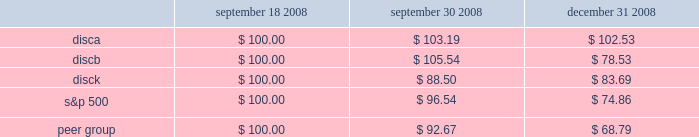2 0 0 8 a n n u a l r e p o r t stock performance graph the following graph sets forth the performance of our series a common , series b common stock , and series c common stock for the period september 18 , 2008 through december 31 , 2008 as compared with the performance of the standard and poor 2019s 500 index and a peer group index which consists of the walt disney company , time warner inc. , cbs corporation class b common stock , viacom , inc .
Class b common stock , news corporation class a common stock , and scripps network interactive , inc .
The graph assumes $ 100 originally invested on september 18 , 2006 and that all subsequent dividends were reinvested in additional shares .
September 18 , september 30 , december 31 , 2008 2008 2008 .
S&p 500 peer group .
How much did the s&p 500 index decline in the fourth quarter? 
Computations: ((96.54 - 74.86) / 74.86)
Answer: 0.28961. 